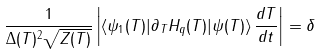<formula> <loc_0><loc_0><loc_500><loc_500>\frac { 1 } { \Delta ( T ) ^ { 2 } \sqrt { Z ( T ) } } \left | \langle \psi _ { 1 } ( T ) | \partial _ { T } H _ { q } ( T ) | \psi ( T ) \rangle \, \frac { d T } { d t } \right | = \delta</formula> 